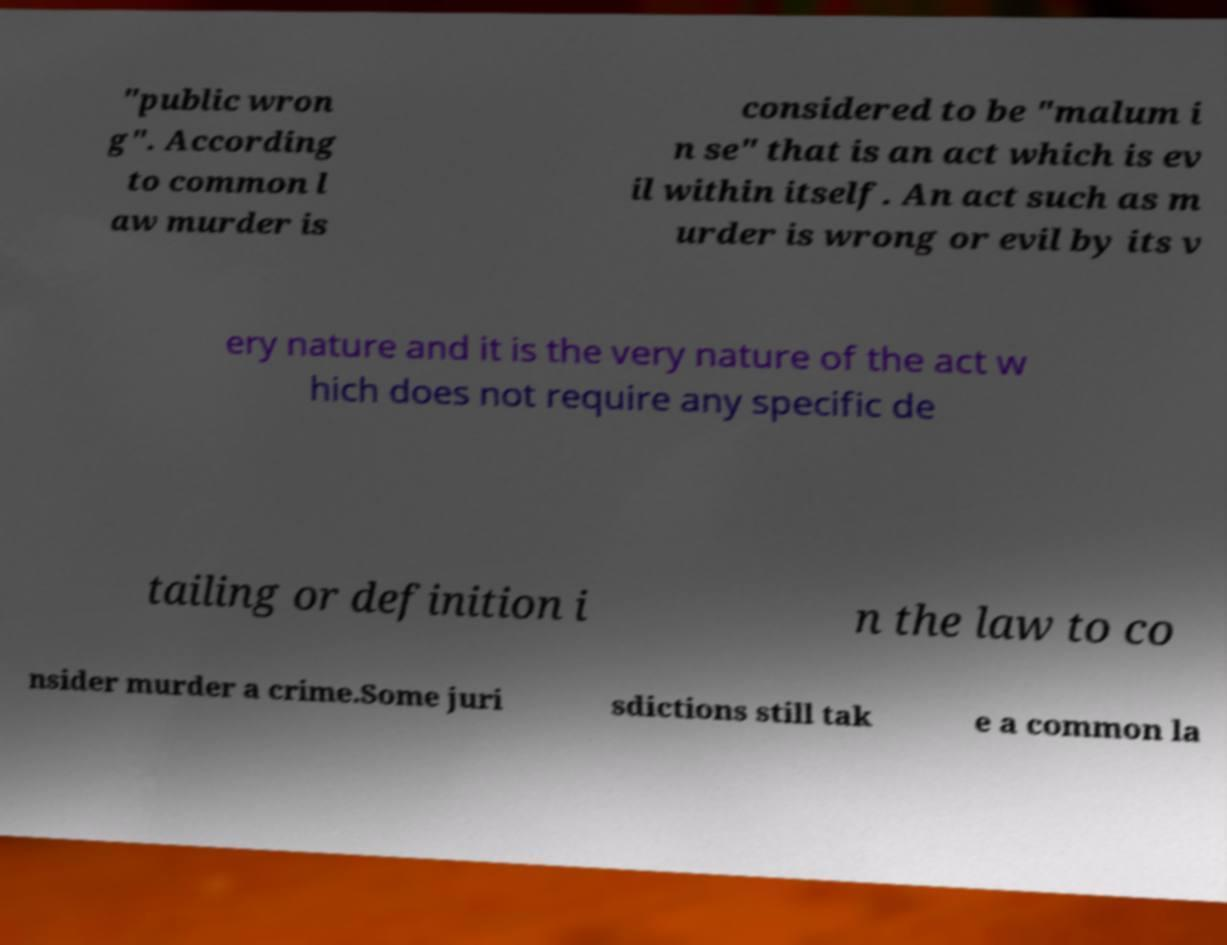Could you extract and type out the text from this image? "public wron g". According to common l aw murder is considered to be "malum i n se" that is an act which is ev il within itself. An act such as m urder is wrong or evil by its v ery nature and it is the very nature of the act w hich does not require any specific de tailing or definition i n the law to co nsider murder a crime.Some juri sdictions still tak e a common la 